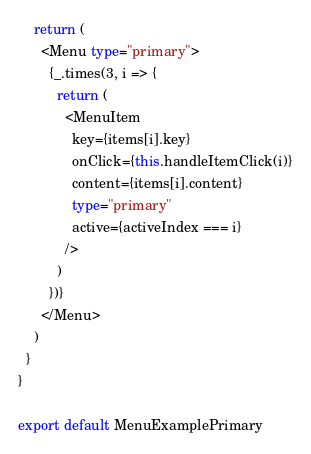Convert code to text. <code><loc_0><loc_0><loc_500><loc_500><_TypeScript_>
    return (
      <Menu type="primary">
        {_.times(3, i => {
          return (
            <MenuItem
              key={items[i].key}
              onClick={this.handleItemClick(i)}
              content={items[i].content}
              type="primary"
              active={activeIndex === i}
            />
          )
        })}
      </Menu>
    )
  }
}

export default MenuExamplePrimary
</code> 